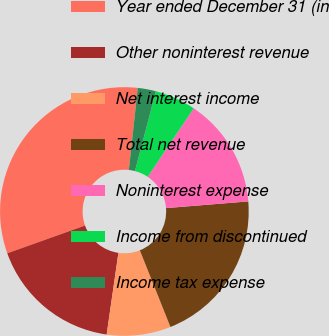Convert chart. <chart><loc_0><loc_0><loc_500><loc_500><pie_chart><fcel>Year ended December 31 (in<fcel>Other noninterest revenue<fcel>Net interest income<fcel>Total net revenue<fcel>Noninterest expense<fcel>Income from discontinued<fcel>Income tax expense<nl><fcel>32.18%<fcel>17.27%<fcel>8.32%<fcel>20.25%<fcel>14.29%<fcel>5.34%<fcel>2.36%<nl></chart> 